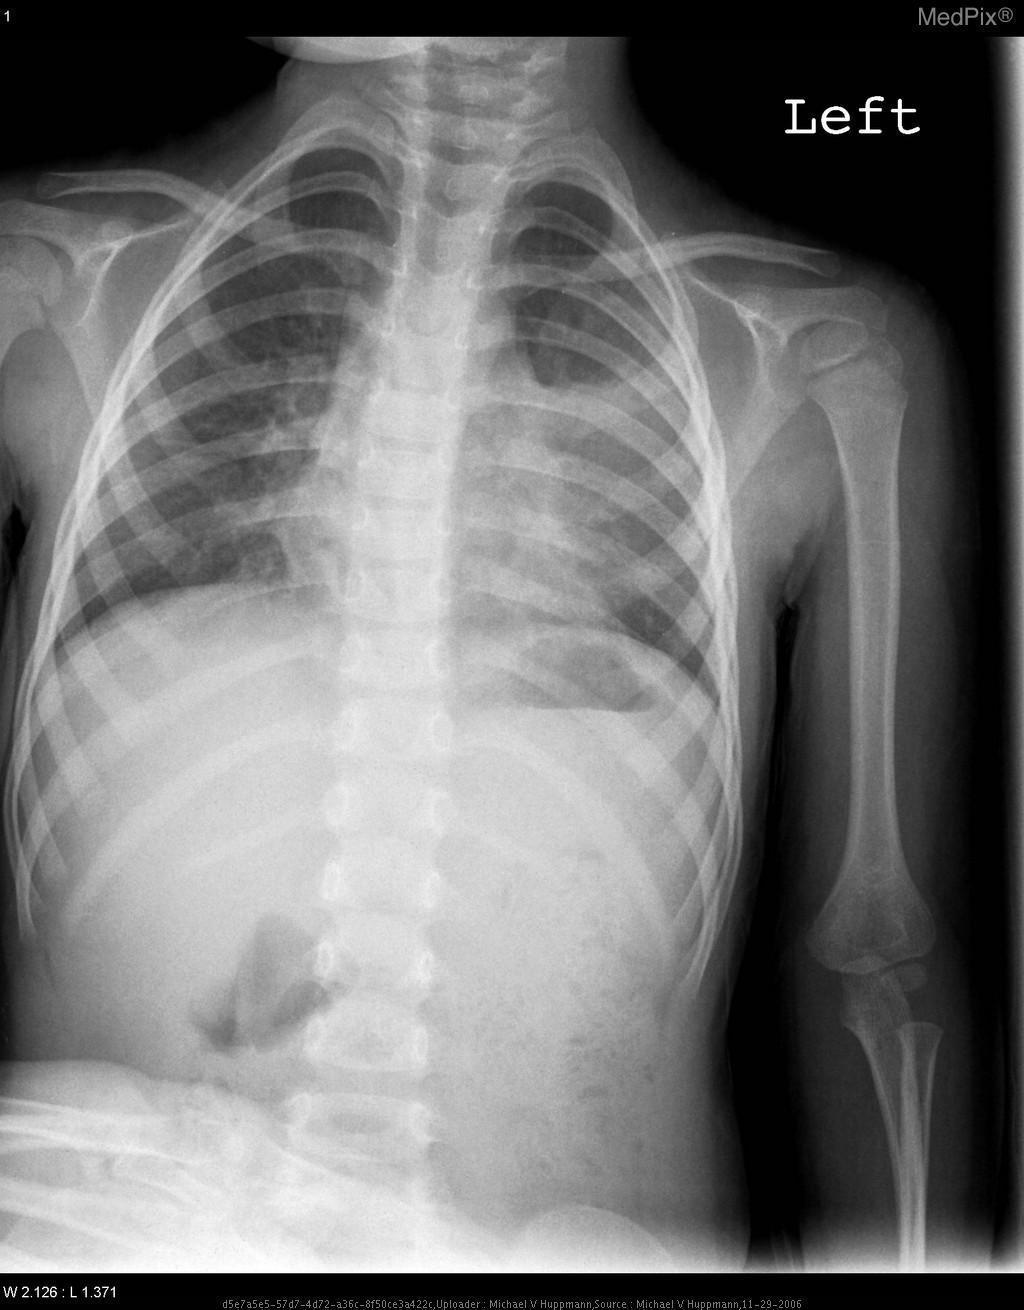Is the heart clearly visible?
Be succinct. No. Is the heart a normal size?
Write a very short answer. Yes. Is the heart size normal?
Answer briefly. Yes. Can this image highlight bone fractures (if present)?
Concise answer only. Yes. Is a pleural effusion present?
Quick response, please. No. Is there a pleural effusion?
Short answer required. No. What can be typically visualized in this plane?
Keep it brief. Lungs 	bony thoracic cavit y	mediastinum and great vessels. Does the left humerus appear to be fractured?
Keep it brief. No. Is there a fracture of the left humerus?
Answer briefly. No. Are both lungs abnormally inflated?
Concise answer only. No. 